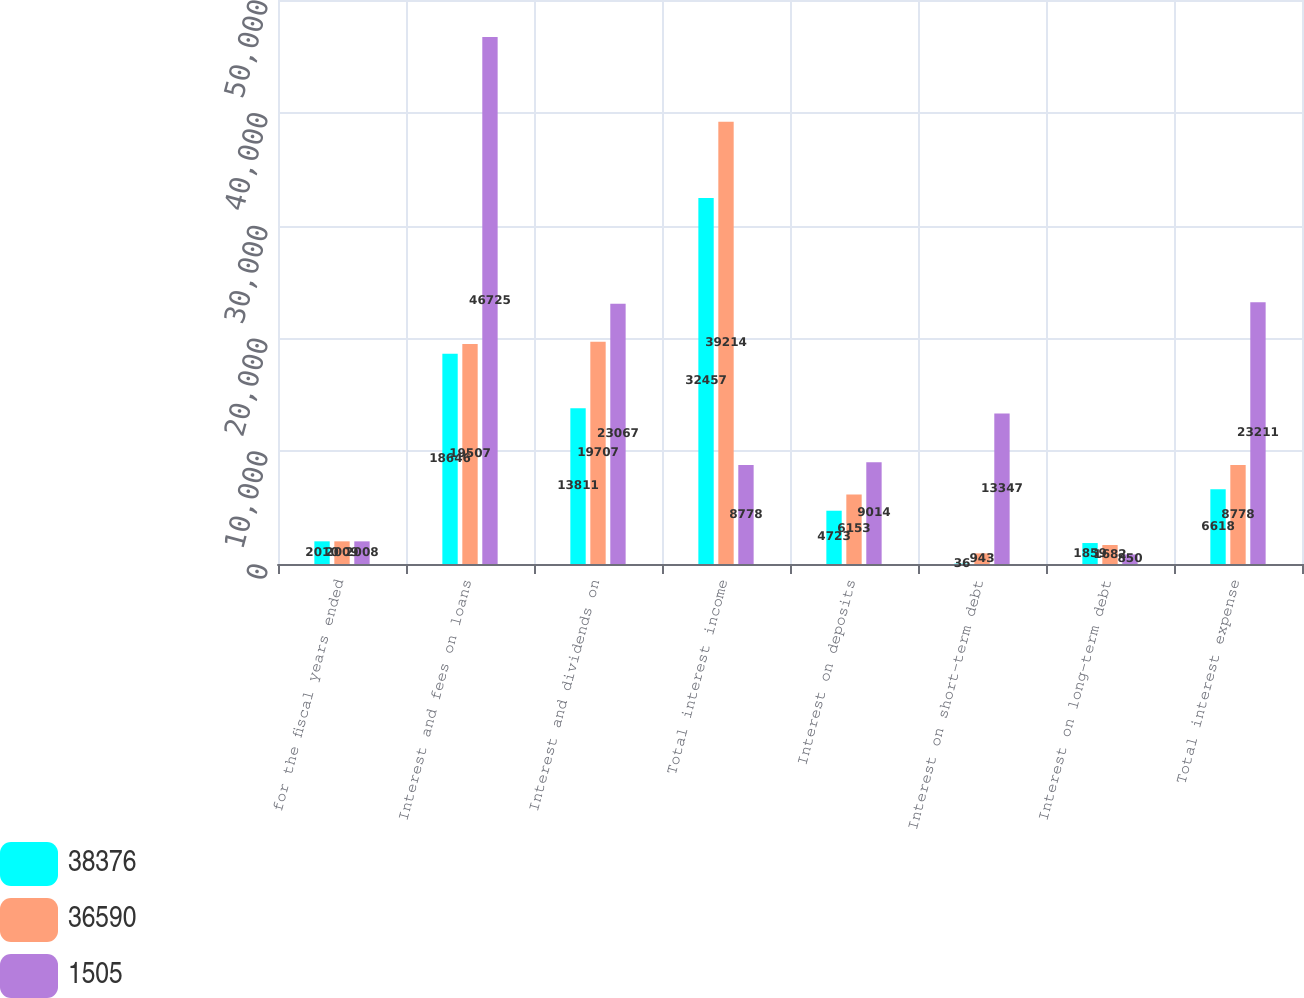Convert chart to OTSL. <chart><loc_0><loc_0><loc_500><loc_500><stacked_bar_chart><ecel><fcel>for the fiscal years ended<fcel>Interest and fees on loans<fcel>Interest and dividends on<fcel>Total interest income<fcel>Interest on deposits<fcel>Interest on short-term debt<fcel>Interest on long-term debt<fcel>Total interest expense<nl><fcel>38376<fcel>2010<fcel>18646<fcel>13811<fcel>32457<fcel>4723<fcel>36<fcel>1859<fcel>6618<nl><fcel>36590<fcel>2009<fcel>19507<fcel>19707<fcel>39214<fcel>6153<fcel>943<fcel>1682<fcel>8778<nl><fcel>1505<fcel>2008<fcel>46725<fcel>23067<fcel>8778<fcel>9014<fcel>13347<fcel>850<fcel>23211<nl></chart> 